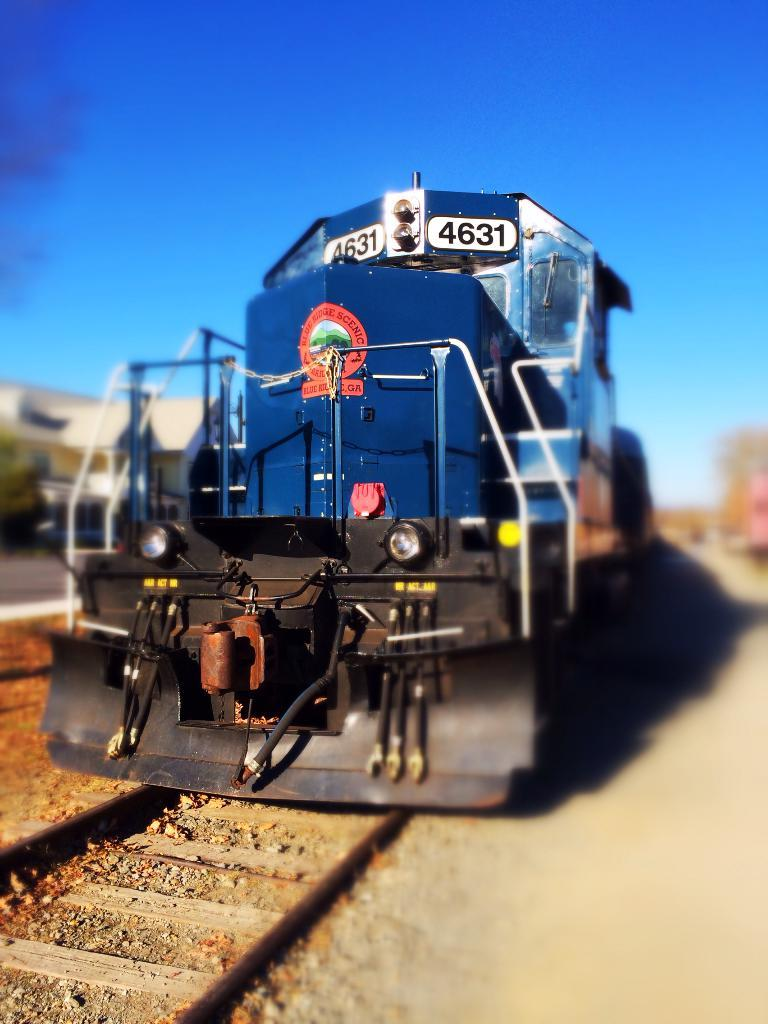What is the main subject of the image? The main subject of the image is a train. Where is the train located in the image? The train is on a railway track. What can be seen on the left side of the image? There is a building and a tree on the left side of the image. What is visible at the top of the image? The sky is visible at the top of the image. What type of office can be seen in the image? There is no office present in the image; it features a train on a railway track, a building, a tree, and the sky. Is there a scarecrow standing near the train in the image? There is no scarecrow present in the image. 